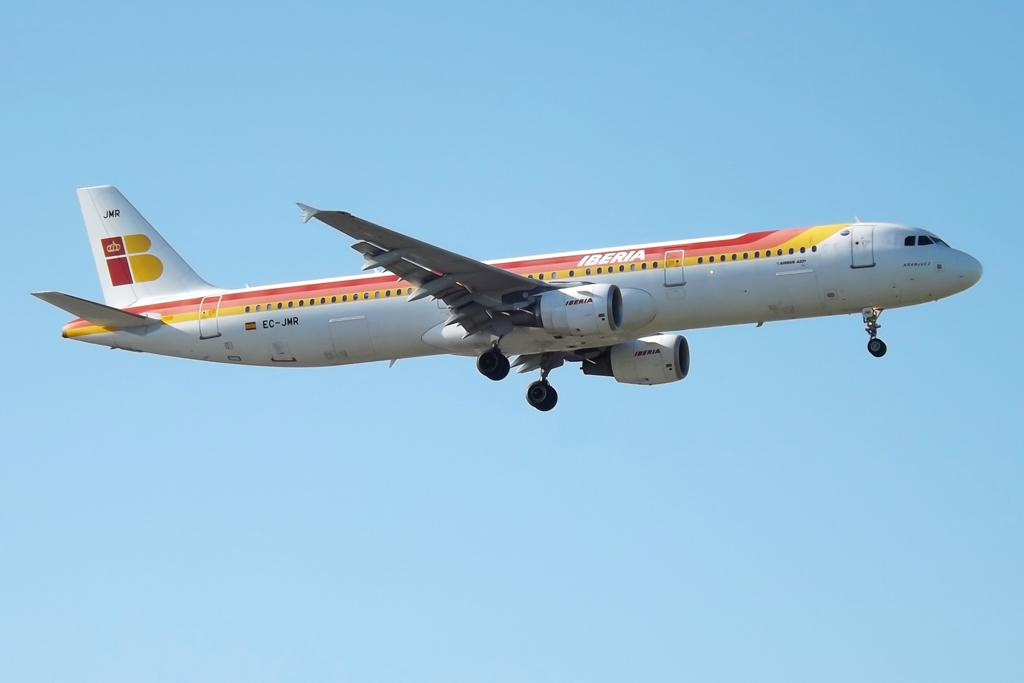Provide a one-sentence caption for the provided image. an airplane flying in the sky called iberia. 